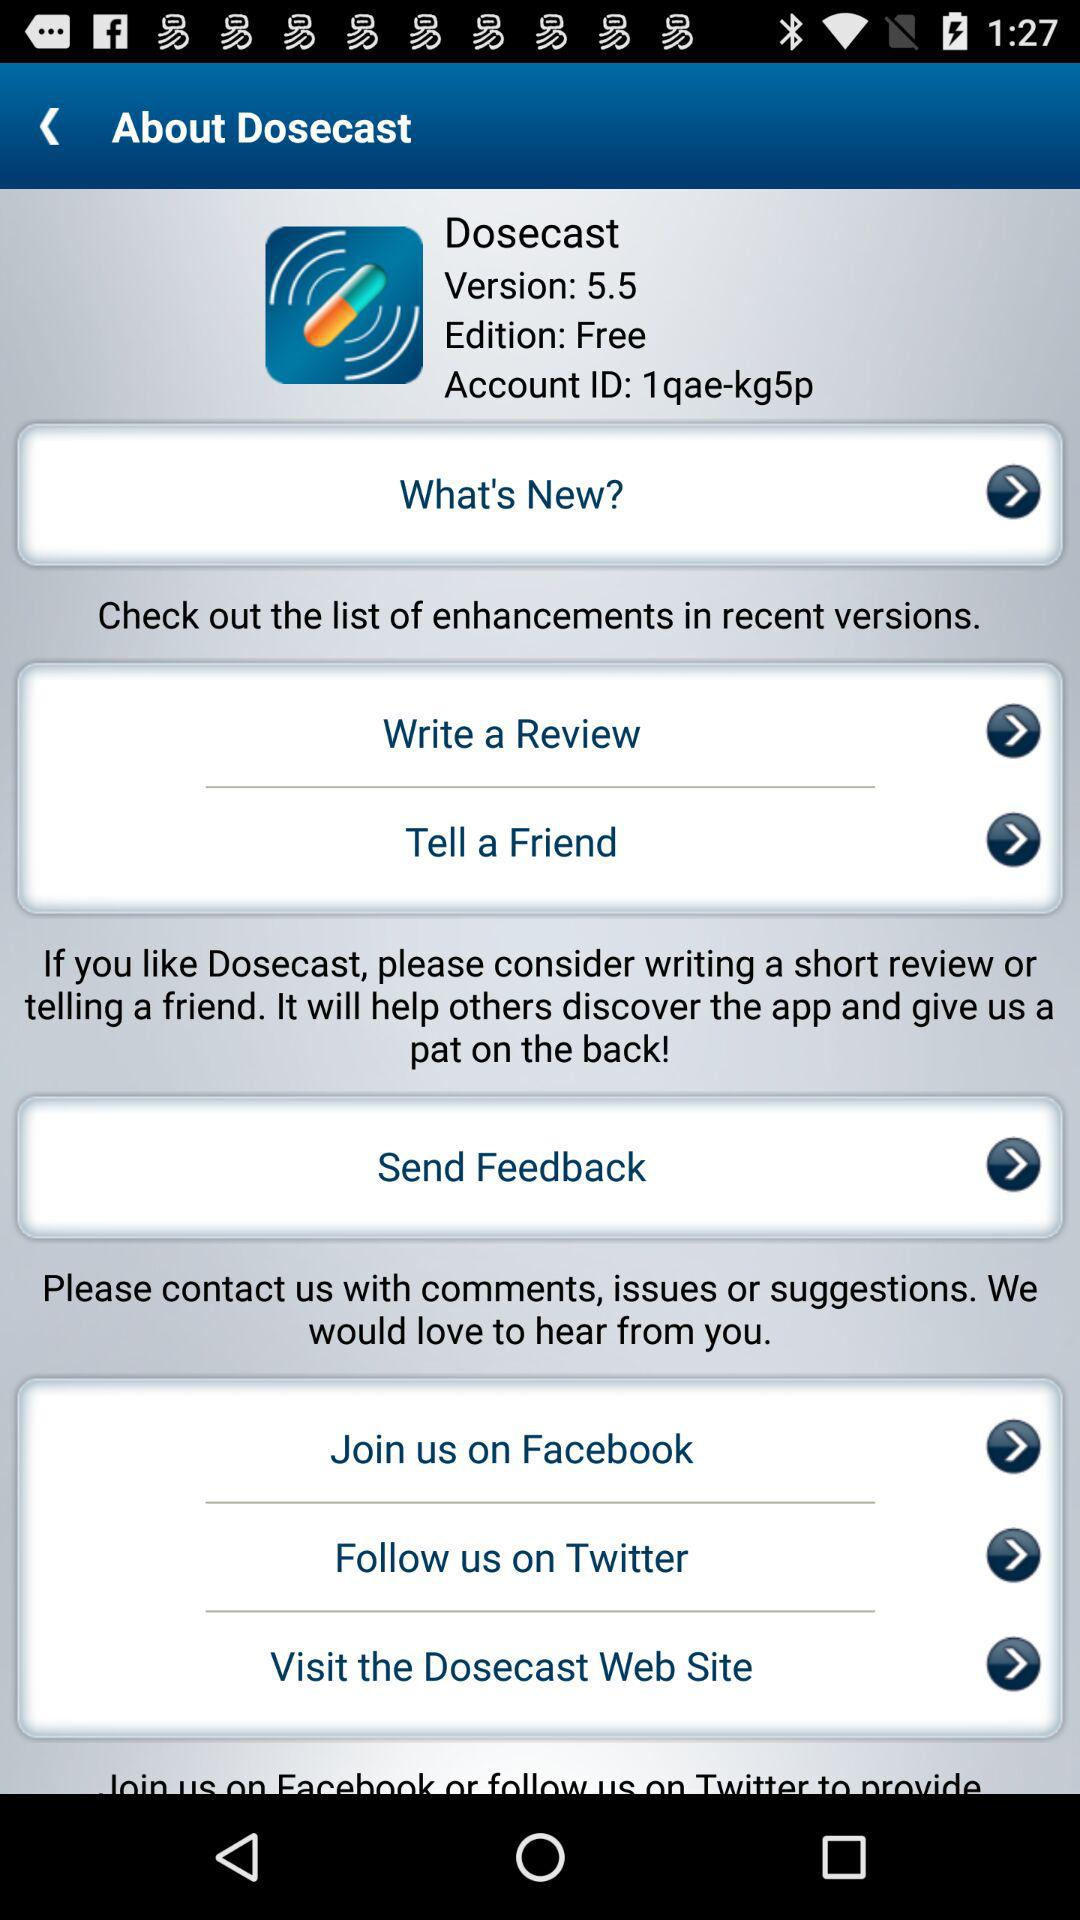What is the app name? The app name is "Dosecast". 